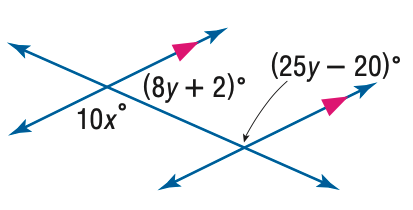Question: Find x in the figure.
Choices:
A. 6
B. 12
C. 13
D. 14
Answer with the letter. Answer: C 